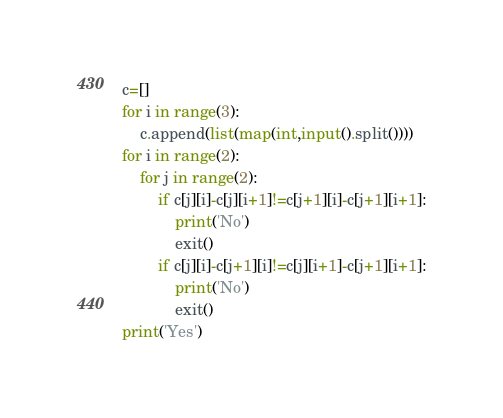<code> <loc_0><loc_0><loc_500><loc_500><_Python_>c=[]
for i in range(3):
    c.append(list(map(int,input().split())))
for i in range(2):
    for j in range(2):
        if c[j][i]-c[j][i+1]!=c[j+1][i]-c[j+1][i+1]:
            print('No')
            exit()
        if c[j][i]-c[j+1][i]!=c[j][i+1]-c[j+1][i+1]:
            print('No')
            exit()
print('Yes')</code> 